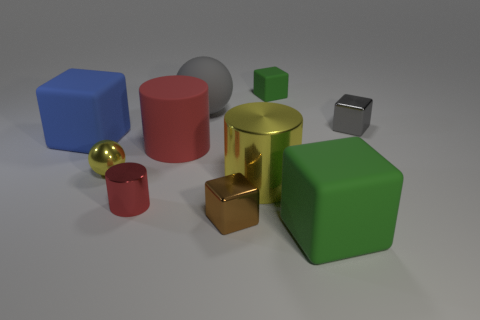Does the big cube to the right of the big yellow metallic cylinder have the same color as the rubber cube behind the large blue object?
Ensure brevity in your answer.  Yes. What size is the metallic block that is on the left side of the green rubber block behind the green cube in front of the yellow ball?
Offer a very short reply. Small. There is a tiny shiny thing that is to the right of the large gray matte thing and to the left of the large green cube; what is its shape?
Make the answer very short. Cube. Are there an equal number of big metallic cylinders that are behind the small shiny sphere and small metallic cubes that are in front of the large blue cube?
Provide a succinct answer. No. Is there a small sphere made of the same material as the blue thing?
Provide a succinct answer. No. Are the large cylinder left of the large yellow metallic thing and the large yellow cylinder made of the same material?
Your answer should be compact. No. There is a matte block that is on the right side of the tiny yellow object and behind the large shiny cylinder; what size is it?
Provide a short and direct response. Small. The big metal cylinder has what color?
Keep it short and to the point. Yellow. How many red cylinders are there?
Your answer should be compact. 2. How many other small metal balls are the same color as the metallic ball?
Provide a succinct answer. 0. 